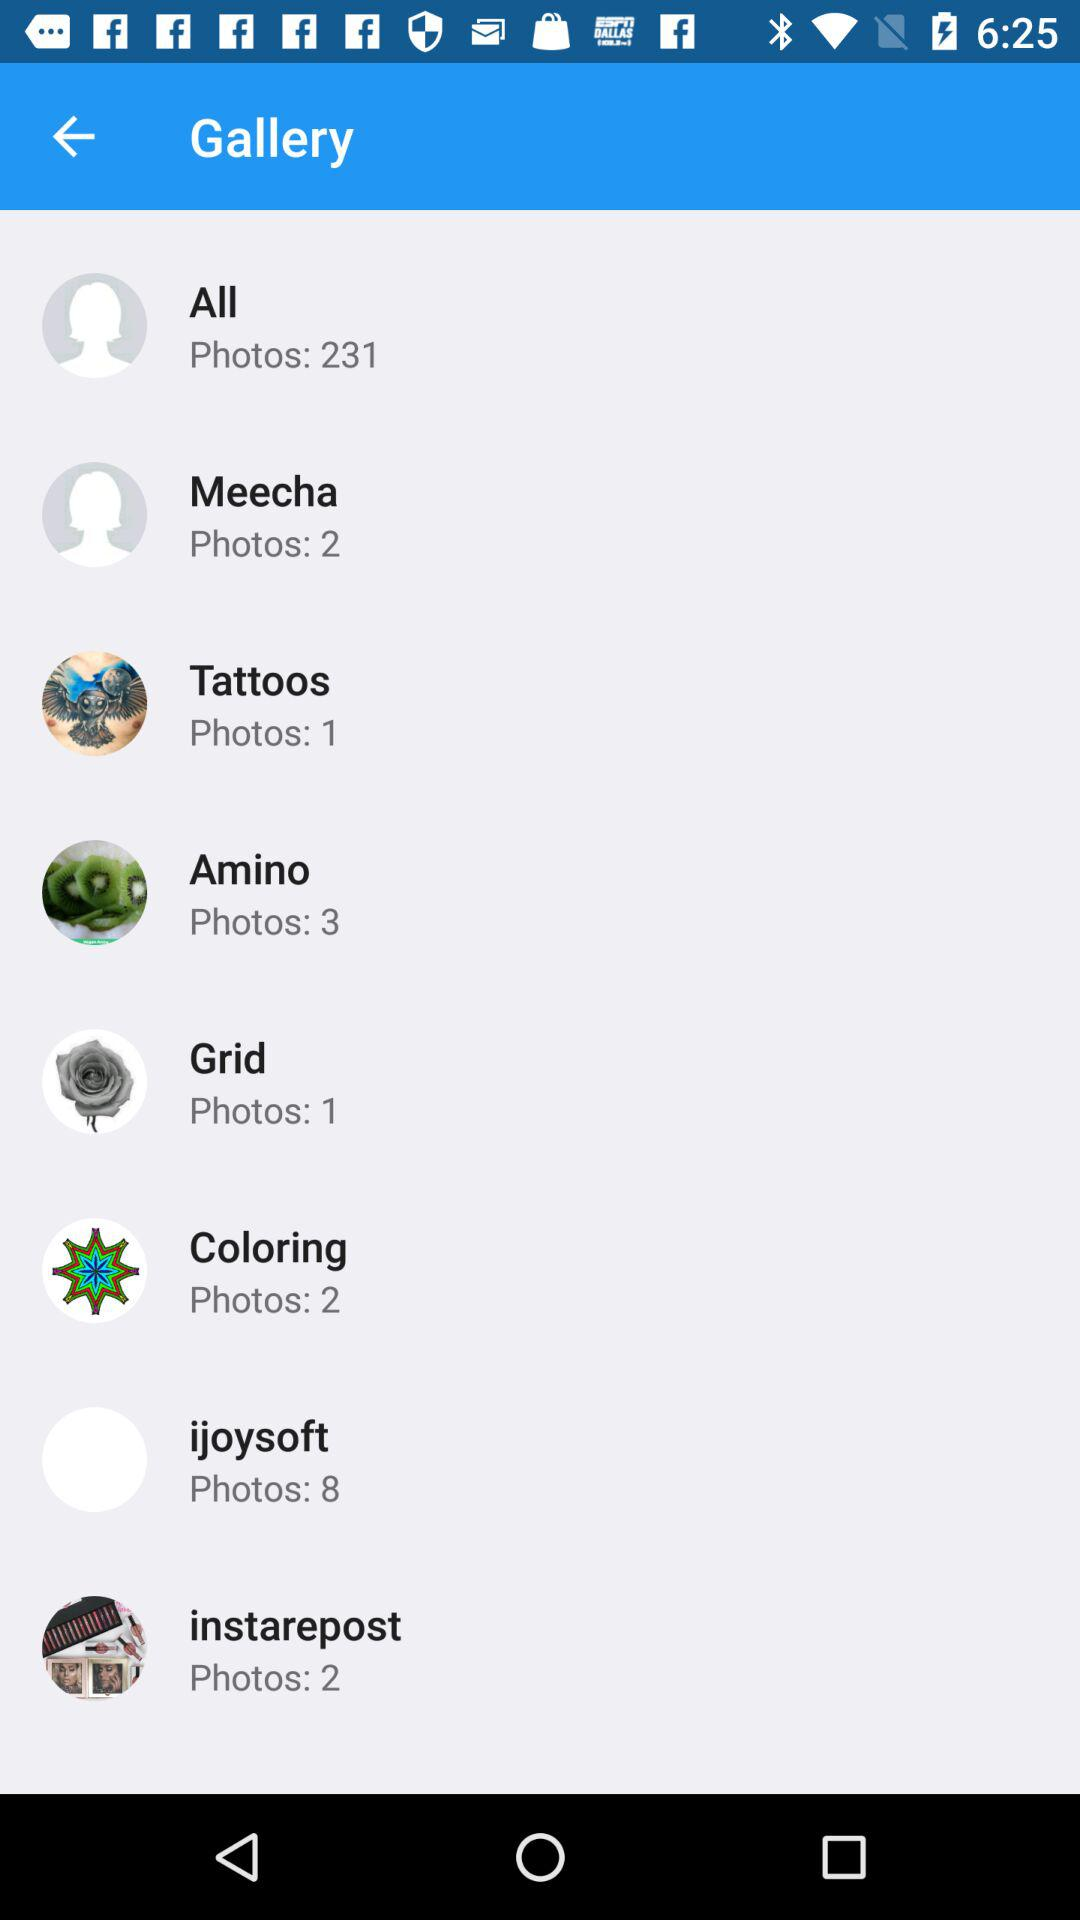Eight photos are present in which gallery? Eight photos are present in the "ijoysoft" gallery. 